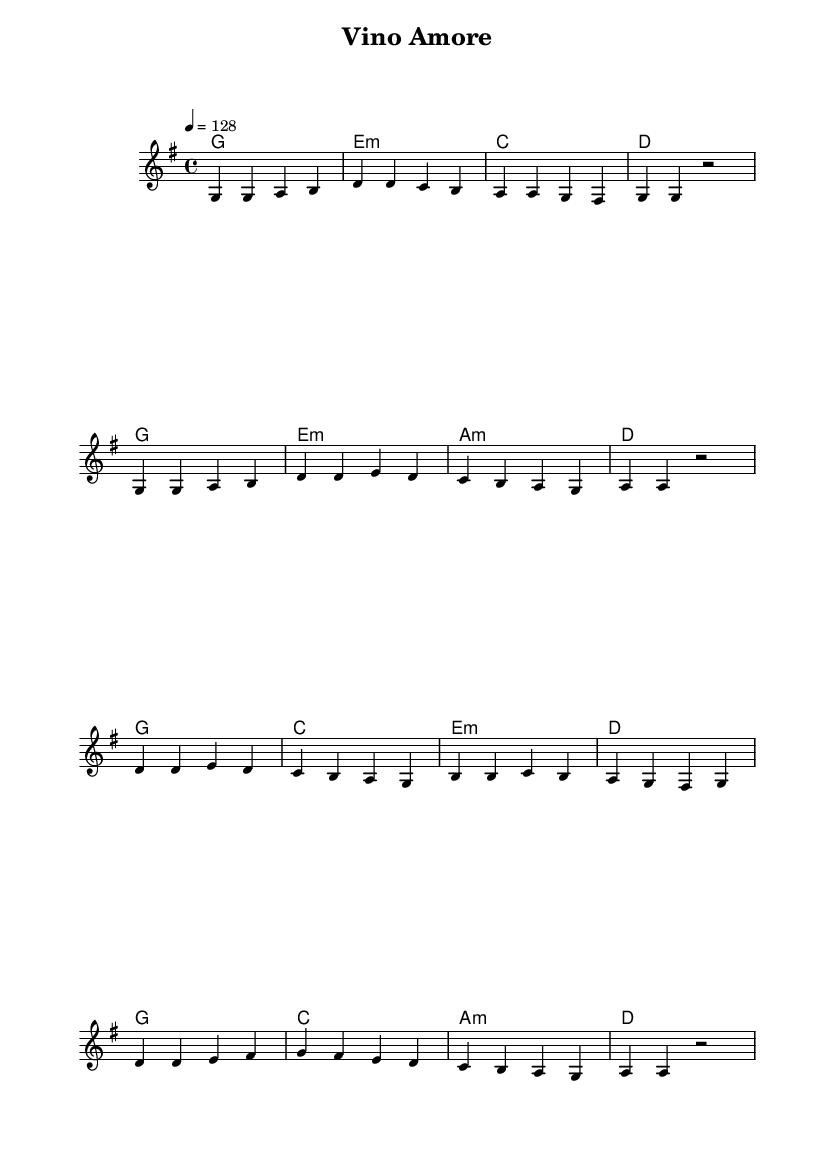What is the key signature of this music? The key signature is G major, which has one sharp (F#). This can be determined by looking at the key indication at the beginning of the score.
Answer: G major What is the time signature of this music? The time signature is 4/4, which means each measure has four beats, and the quarter note gets one beat. This is indicated at the start of the piece.
Answer: 4/4 What is the tempo marking for this piece? The tempo marking is 128 beats per minute. This is indicated by "4 = 128" which means the quarter note is equal to 128 beats per minute.
Answer: 128 How many measures are in the chorus section? The chorus section comprises 8 measures. By counting the measures from the beginning of the chorus to the end, we see that there are 8 distinct measures.
Answer: 8 Which chord is prominent in the verse? The prominent chord in the verse is G major, which is indicated first in the progression and recurs frequently throughout the verse section.
Answer: G major What type of chord uses a minor third interval in this piece? The chord that uses a minor third interval in this piece is E minor, as noted by the "e1:m" notation in the harmonies indicating a minor triad.
Answer: E minor What is the musical style represented by this sheet music? The musical style represented by this sheet music is K-Pop, characterized by its upbeat tempo and catchy melody, typical for dance tracks in this genre.
Answer: K-Pop 